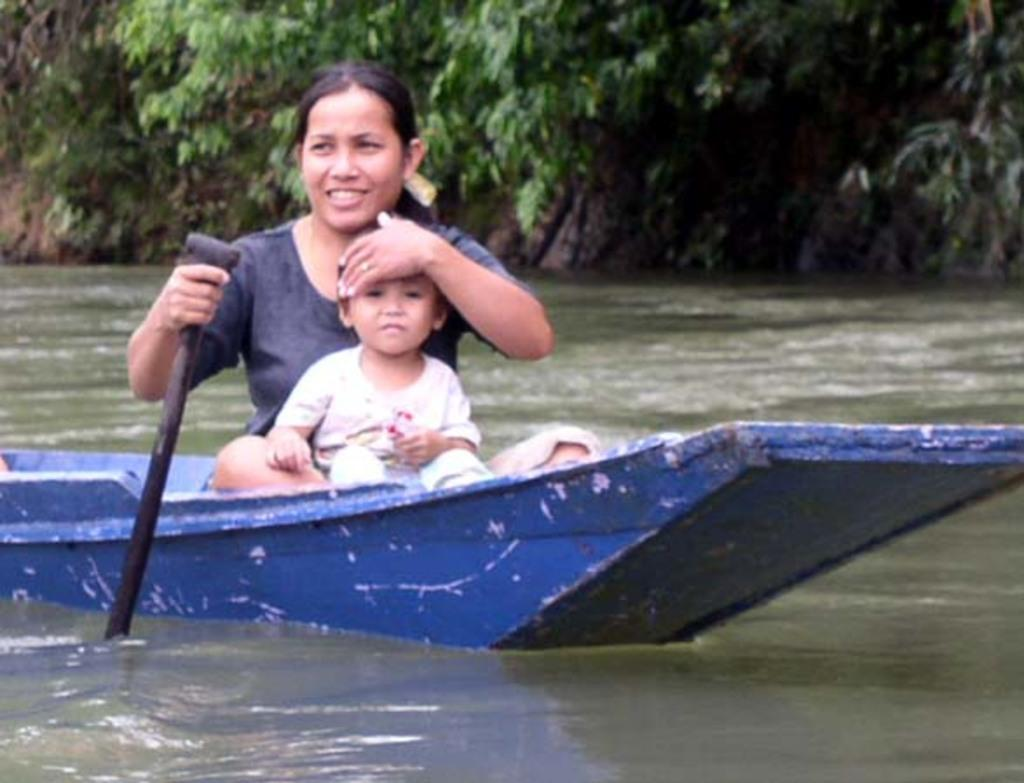Who is present in the image? There is a woman and a kid in the image. What are they doing in the image? Both the woman and the kid are sitting in a canoe. What is the woman holding in the image? The woman is holding a paddle. What is the setting of the image? The canoe is surrounded by water, and there are trees visible in the background. What type of iron and silver are present in the image? There is no iron or silver present in the image; it features a woman and a kid in a canoe surrounded by water and trees. 